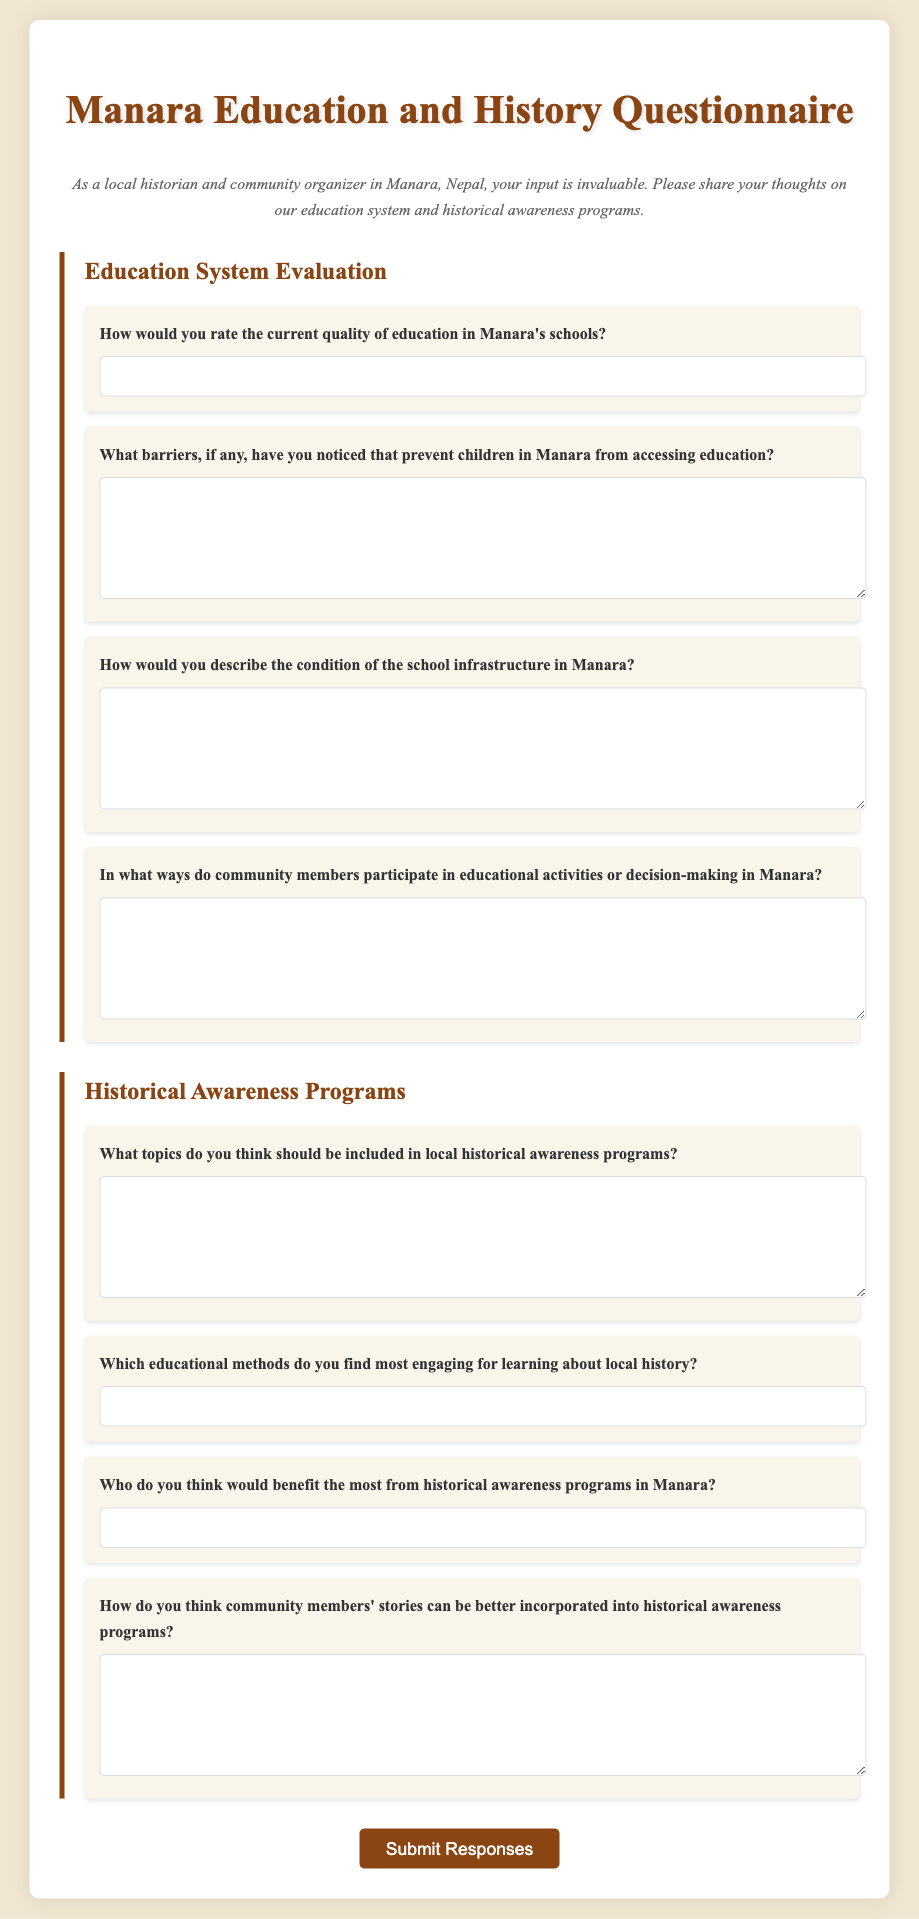What is the title of the questionnaire? The title of the questionnaire is displayed prominently at the top of the document.
Answer: Manara Education and History Questionnaire Who is the intended audience for this questionnaire? The introduction specifies who the questionnaire is targeting.
Answer: Local historians and community organizers How many sections are in the questionnaire? The document is divided into two main sections for evaluation.
Answer: Two What are the two main focus areas of the questionnaire? The sections header indicates the topics covered.
Answer: Education System Evaluation and Historical Awareness Programs What type of input is required for question 4? The question type is indicated by the fields in the form.
Answer: Textarea Which question asks about barriers to education? The question number and content can be referenced directly from the document.
Answer: Question 2 What is the background color of the questionnaire? The background color for the document is mentioned in the style section.
Answer: #f0e6d2 What will happen after clicking the submit button? The function of the button is inferred by its label and typical form behavior.
Answer: Submit Responses What topic does question 5 focus on? The content of the question directly states its focus area.
Answer: Local historical awareness programs 